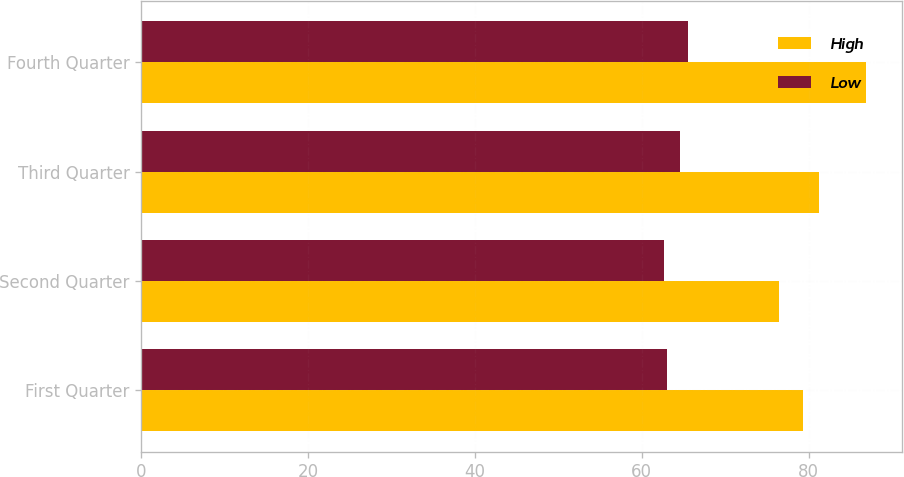<chart> <loc_0><loc_0><loc_500><loc_500><stacked_bar_chart><ecel><fcel>First Quarter<fcel>Second Quarter<fcel>Third Quarter<fcel>Fourth Quarter<nl><fcel>High<fcel>79.34<fcel>76.47<fcel>81.2<fcel>86.84<nl><fcel>Low<fcel>63.03<fcel>62.68<fcel>64.53<fcel>65.56<nl></chart> 